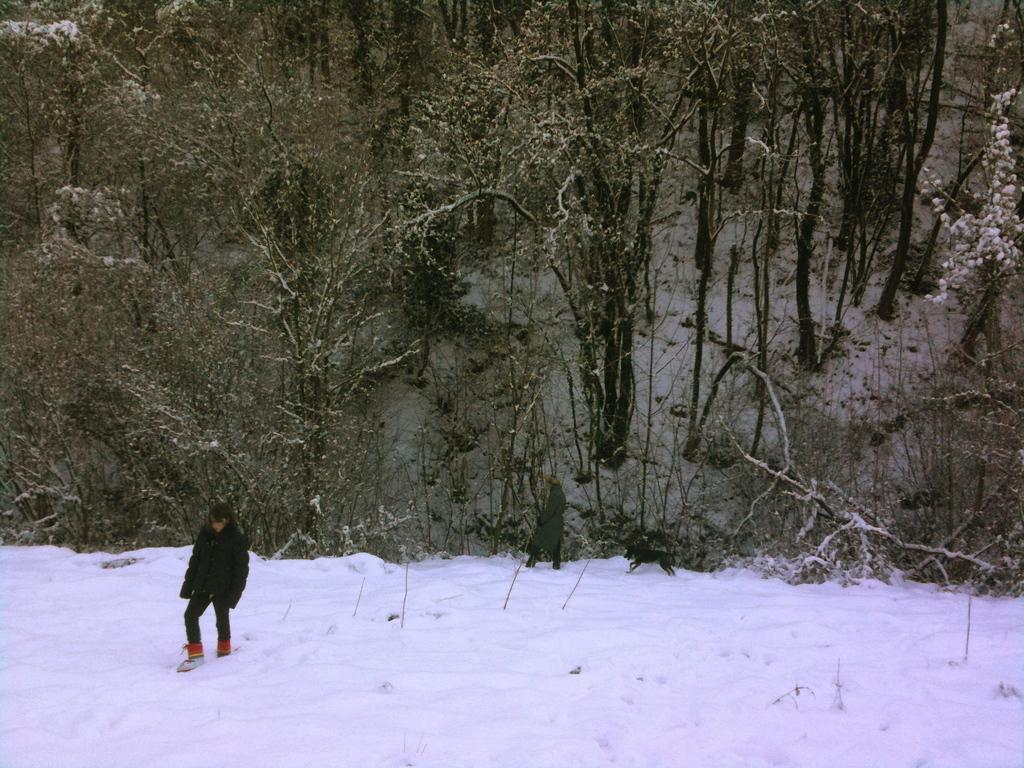What is the person in the image doing? The person is walking in the snow on the left side of the image. What is the person wearing while walking in the snow? The person is wearing a black coat. What can be seen in the background of the image? There are trees in the image. What type of hope can be seen floating in the snow in the image? There is no hope present in the image, as hope is an abstract concept and cannot be seen or depicted visually. 